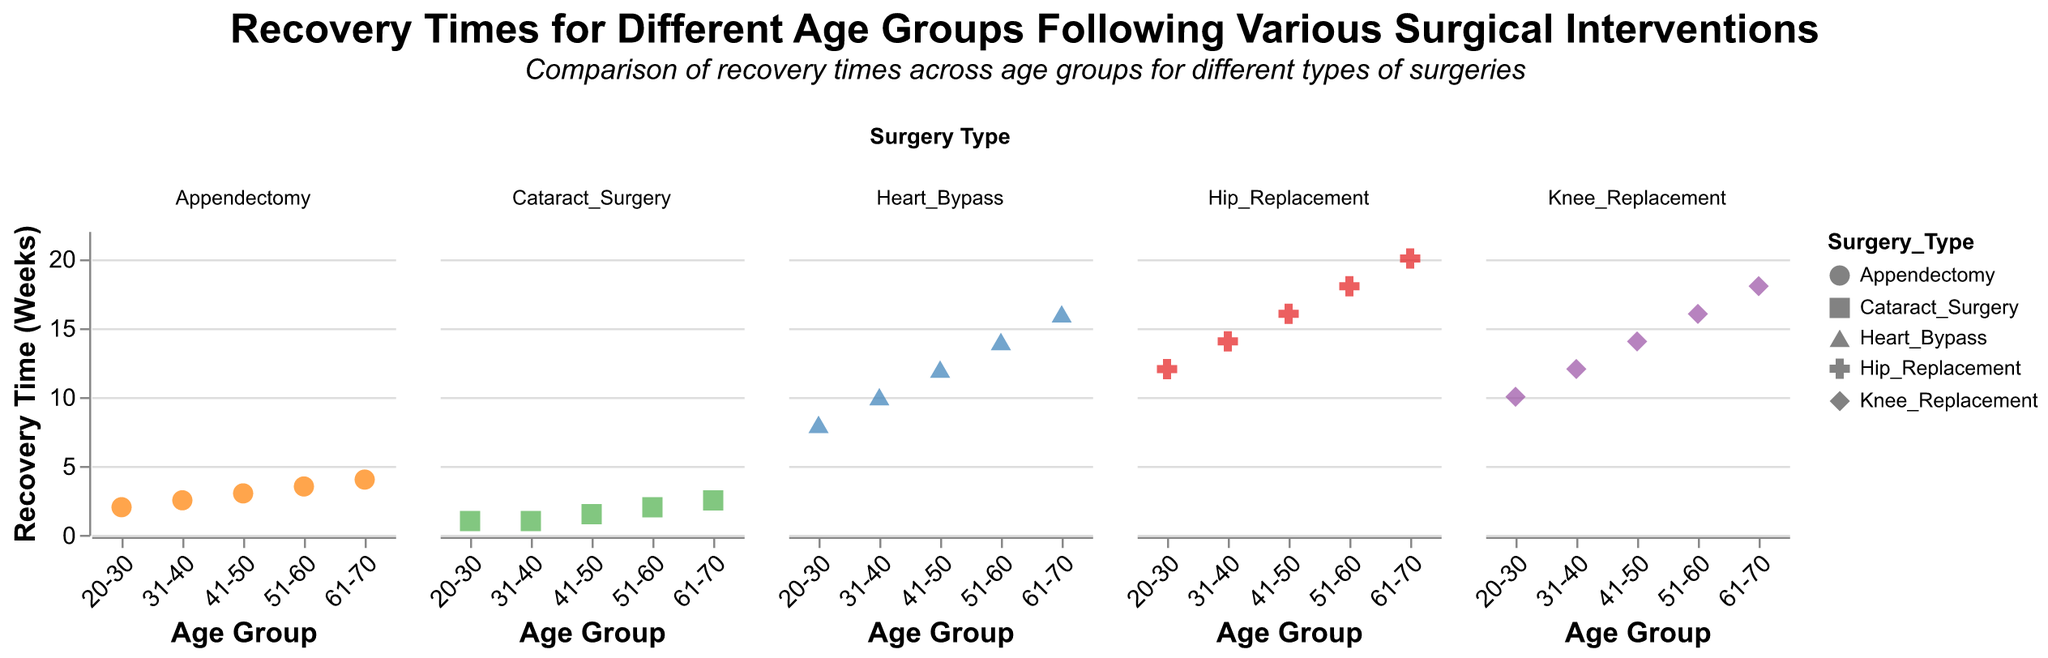What is the title of the chart? The title of the chart is displayed at the top and provides a clear description of what the chart is about.
Answer: Recovery Times for Different Age Groups Following Various Surgical Interventions How many surgical types are compared in the plot? There are different columns for each surgery type, and counting these columns will give us the number of surgical types compared.
Answer: 5 Which age group has the shortest recovery time for Heart Bypass surgery? By examining the 'Heart_Bypass' subplot and looking at the lowest value on the y-axis for recovery time, we find the shortest recovery time among the age groups.
Answer: 20-30 Which surgery type has the highest recovery time and for which age group? We look across all subplots to identify the highest point on the y-axis and note the corresponding age group and surgery type.
Answer: Hip Replacement, 61-70 What is the average recovery time for the Knee Replacement surgery for all age groups? Add up the recovery times for Knee Replacement for each age group: \(10 + 12 + 14 + 16 + 18 = 70\), then divide by the number of age groups (5).
Answer: (10+12+14+16+18)/5 = 70/5 = 14 How does the recovery time trend vary with age for Appendectomy surgery? Check the trend line for Appendectomy across age groups, noting the pattern in recovery time changes.
Answer: Increases with age Compare the recovery times between the age groups 41-50 and 51-60 for Cataract Surgery. Look at the values in the Cataract Surgery subplot for these age groups and compare them. 41-50 has a recovery time of 1.5 and 51-60 has a recovery time of 2.
Answer: Recovery time is higher in the 51-60 age group What is the difference in recovery time between the youngest and oldest age groups for Hip Replacement surgery? Subtract the recovery time of the 20-30 age group from the 61-70 age group in the Hip Replacement subplot. \(20 - 12 = 8\).
Answer: 8 weeks How does the recovery time for Cataract Surgery compare across all age groups? Examine the Cataract Surgery subplot and observe the recovery time values for each age group, noting how they are relatively short and increase slightly with age.
Answer: Recovery time is quite short and increases slightly with age Rank the surgeries from shortest to longest recovery time for the age group 61-70. List the recovery times for age group 61-70 for all surgery types: Appendectomy (4), Hip Replacement (20), Heart Bypass (16), Cataract Surgery (2.5), Knee Replacement (18), and order them.
Answer: Cataract Surgery, Appendectomy, Heart Bypass, Knee Replacement, Hip Replacement 